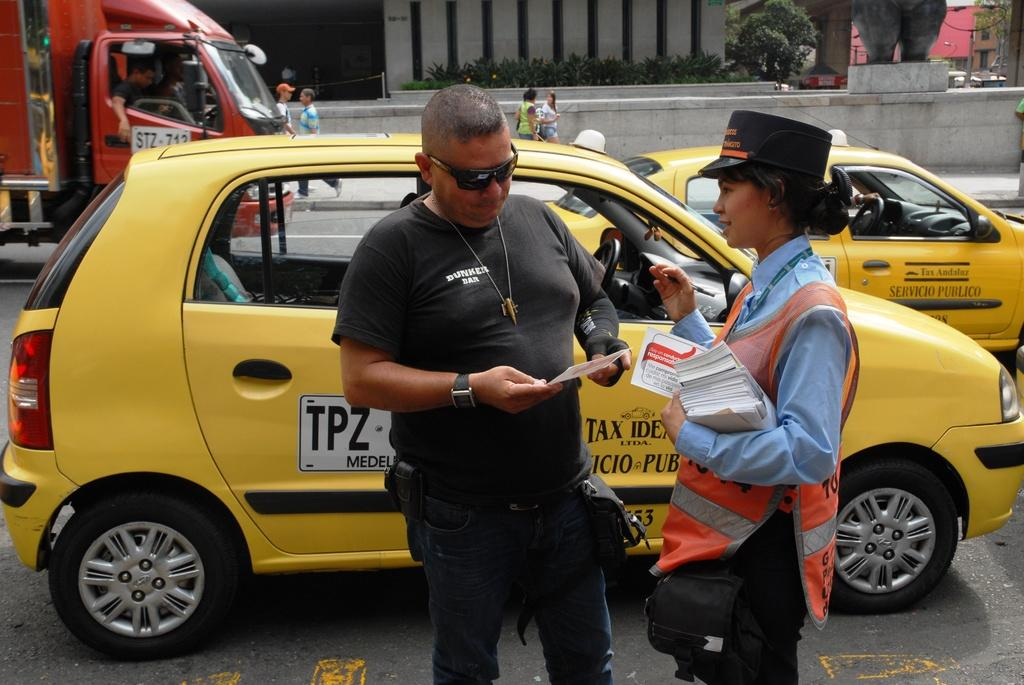<image>
Render a clear and concise summary of the photo. A man is looking at a flyer that a women handed him and the car behind them says TPZ. 